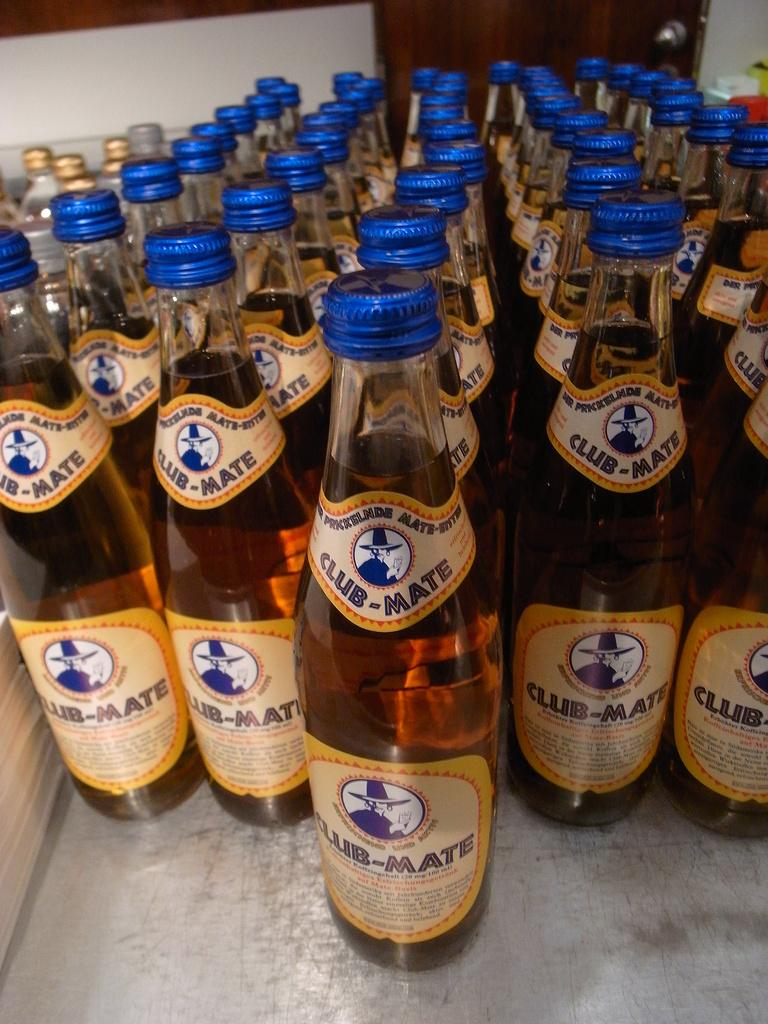<image>
Provide a brief description of the given image. A table full of bottles of Club-Mate beer. 